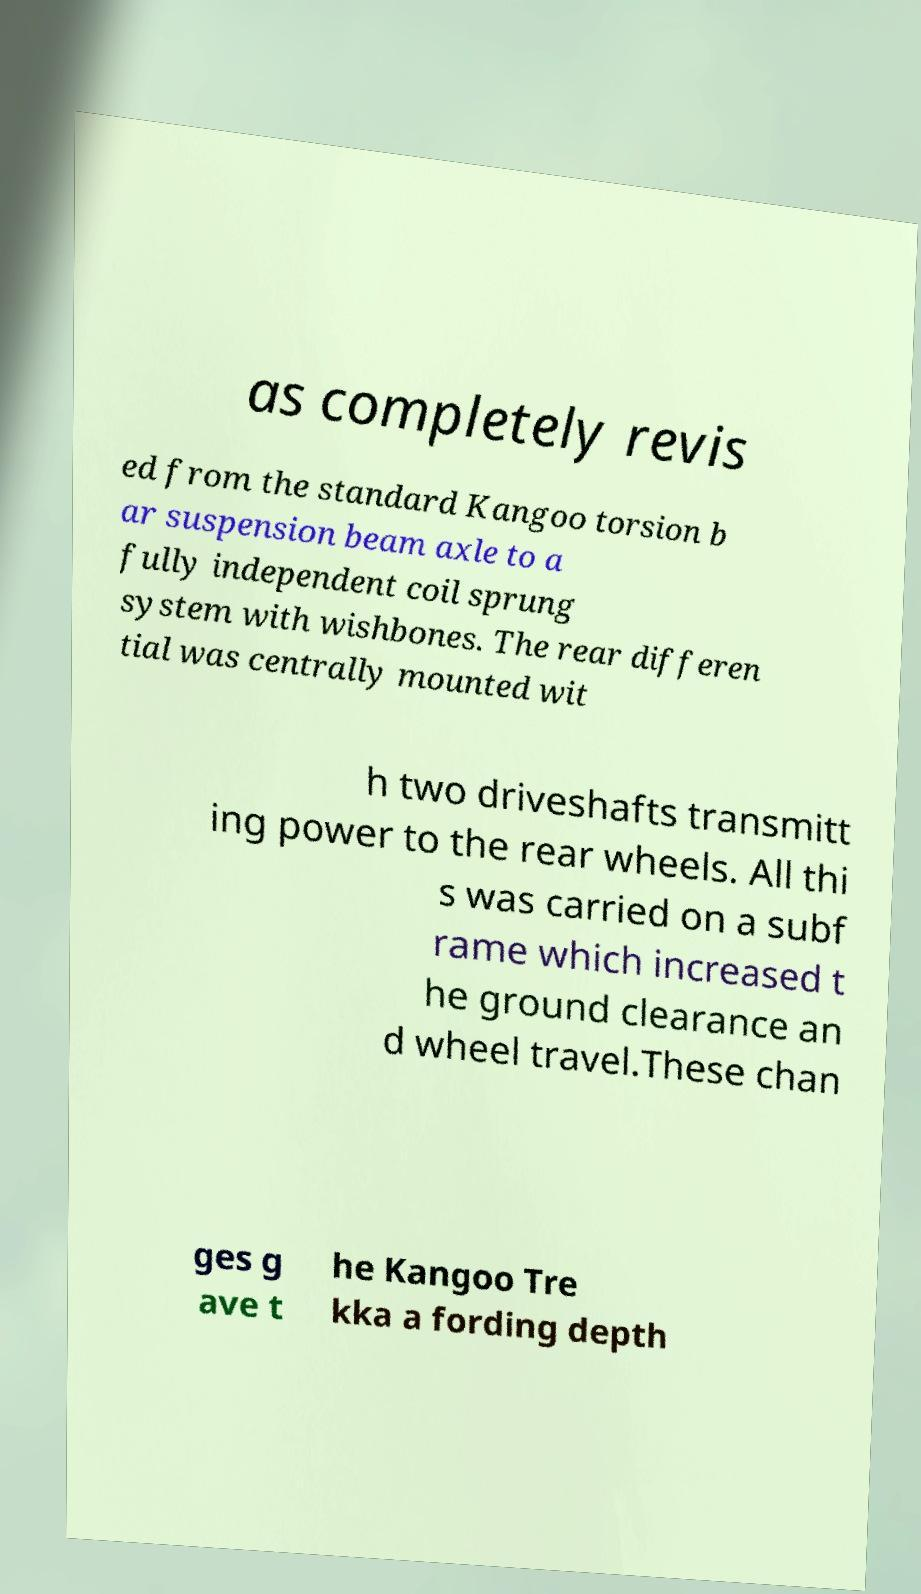Could you assist in decoding the text presented in this image and type it out clearly? as completely revis ed from the standard Kangoo torsion b ar suspension beam axle to a fully independent coil sprung system with wishbones. The rear differen tial was centrally mounted wit h two driveshafts transmitt ing power to the rear wheels. All thi s was carried on a subf rame which increased t he ground clearance an d wheel travel.These chan ges g ave t he Kangoo Tre kka a fording depth 